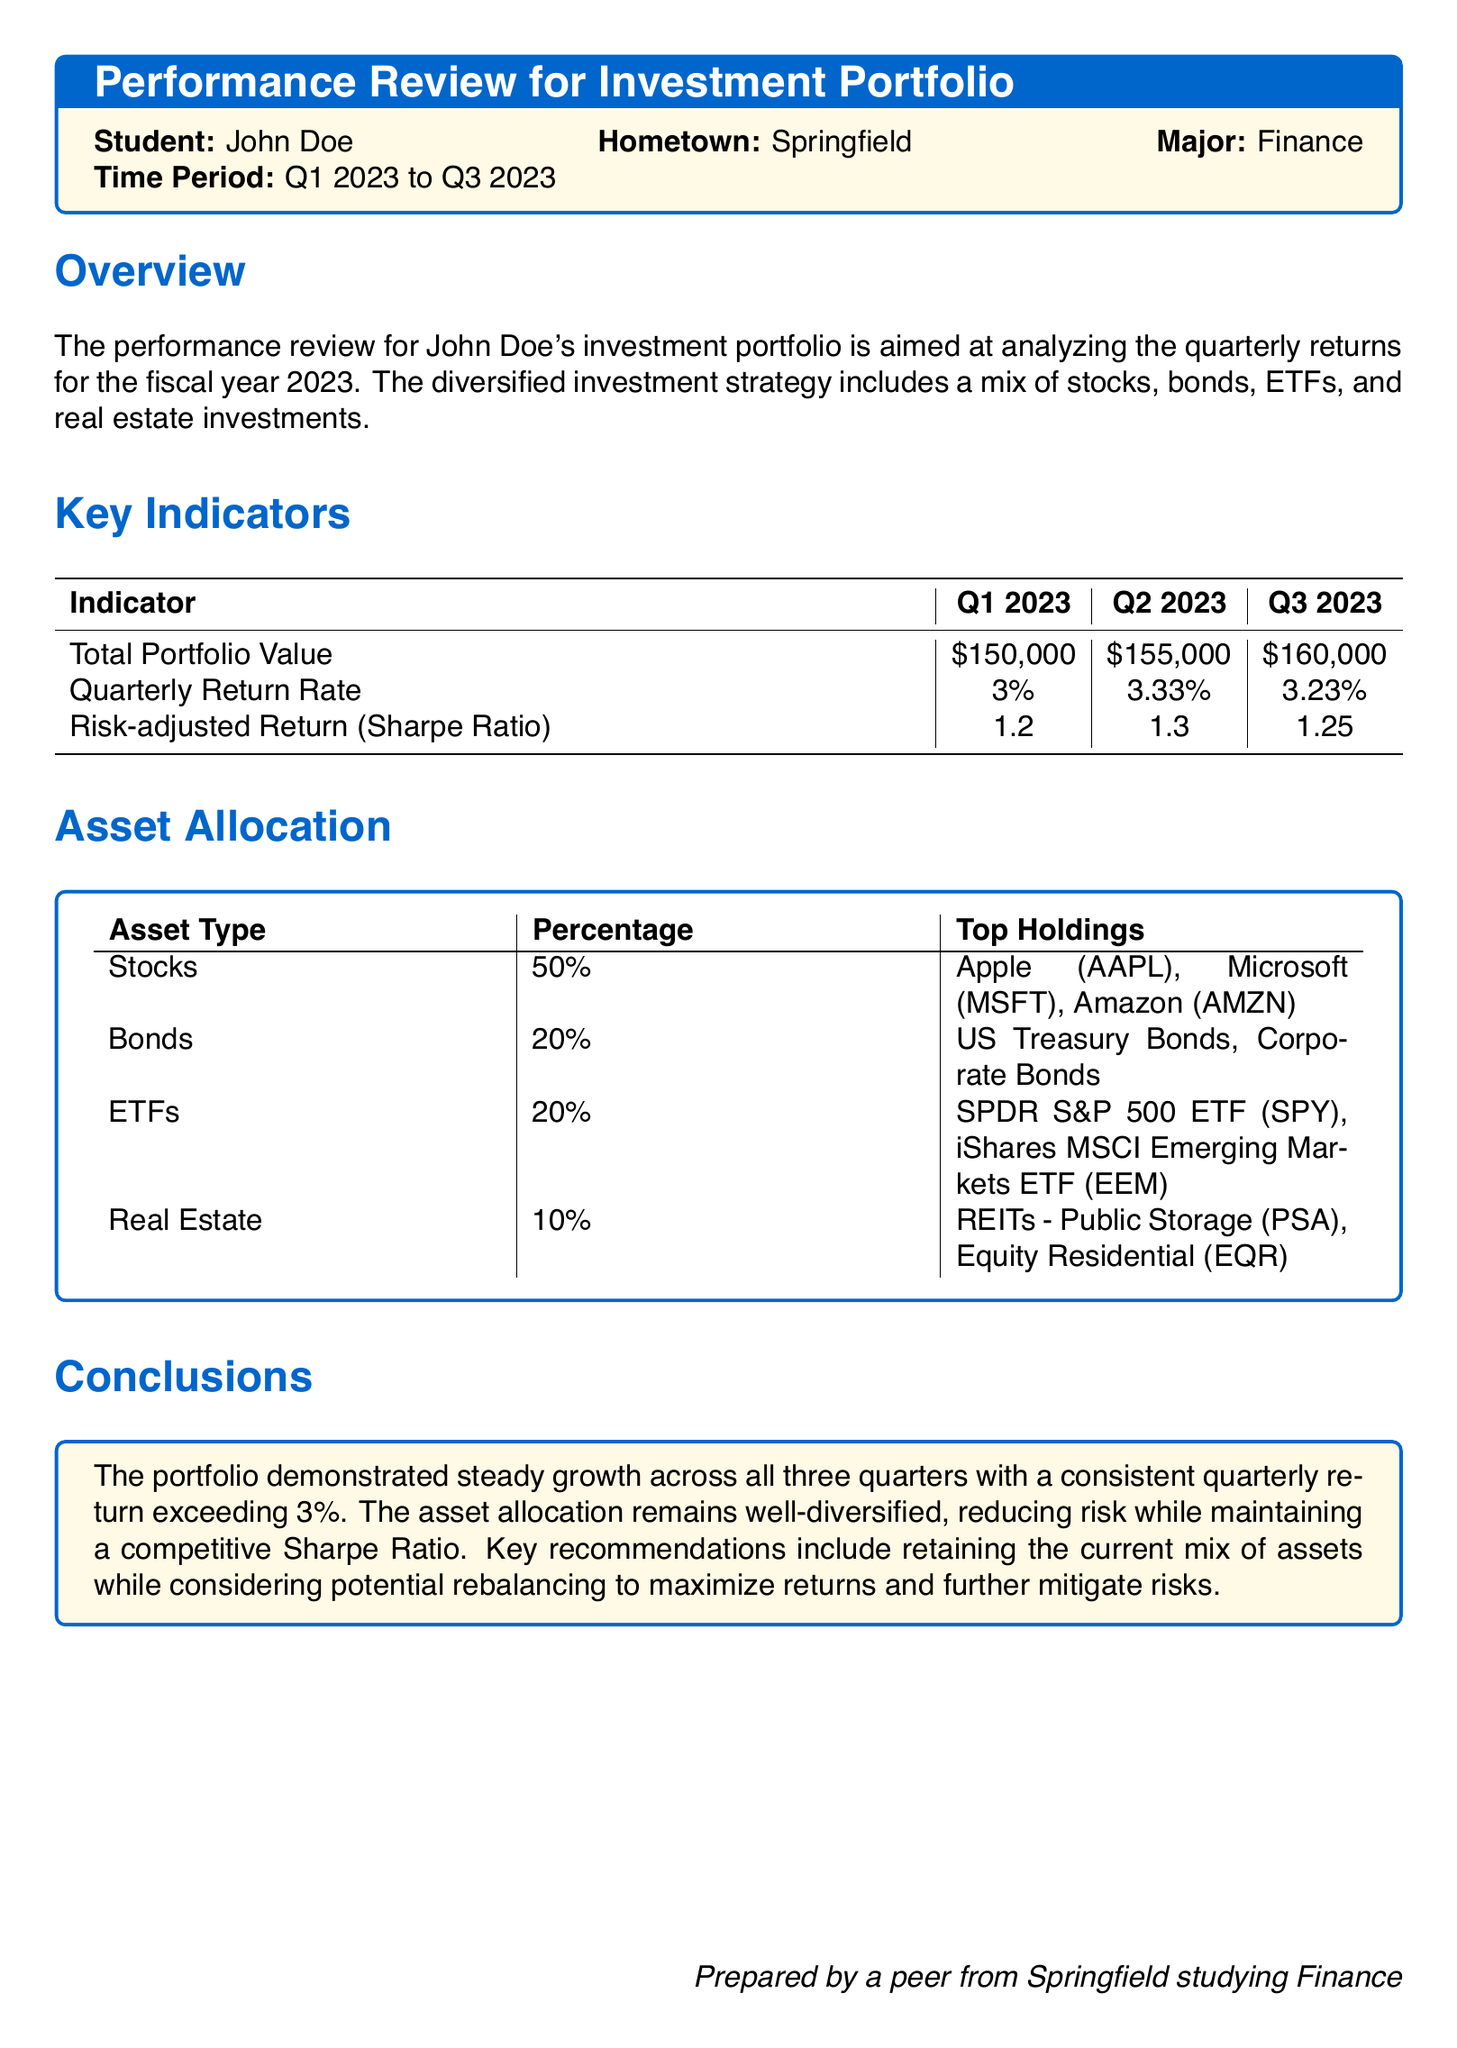what was the total portfolio value in Q2 2023? The total portfolio value in Q2 2023 is specified in the document as $155,000.
Answer: $155,000 what is the quarterly return rate for Q1 2023? The quarterly return rate for Q1 2023 is listed as 3%.
Answer: 3% which asset type has the highest percentage allocation? The asset type with the highest percentage allocation, as stated in the document, is Stocks at 50%.
Answer: Stocks what was the Sharpe Ratio in Q3 2023? The Sharpe Ratio for Q3 2023 is mentioned in the document as 1.25.
Answer: 1.25 how much did the total portfolio value increase from Q1 to Q3 2023? The increase in total portfolio value is calculated by subtracting the Q1 value of $150,000 from the Q3 value of $160,000, resulting in a $10,000 increase.
Answer: $10,000 which two stocks are among the top holdings in the portfolio? The document lists Apple (AAPL) and Microsoft (MSFT) as two of the top holdings in the Stocks category.
Answer: Apple (AAPL), Microsoft (MSFT) what is the recommended action for the asset allocation? The document suggests retaining the current mix of assets while considering potential rebalancing.
Answer: Retaining and rebalancing which quarter had the highest quarterly return rate? The highest quarterly return rate is provided for Q2 2023, which is 3.33%.
Answer: Q2 2023 what is the asset type allocation percentage for Real Estate? The document shows that Real Estate is allocated 10% of the investment portfolio.
Answer: 10% what are the top holdings in the ETF category? The document specifies the top holdings in ETFs as SPDR S&P 500 ETF (SPY) and iShares MSCI Emerging Markets ETF (EEM).
Answer: SPDR S&P 500 ETF (SPY), iShares MSCI Emerging Markets ETF (EEM) 